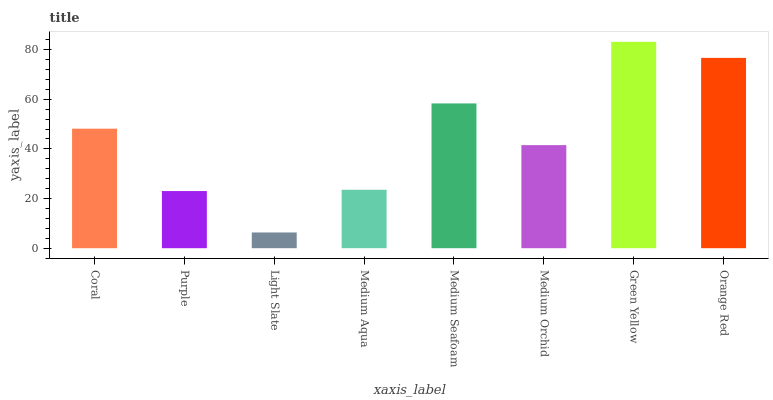Is Light Slate the minimum?
Answer yes or no. Yes. Is Green Yellow the maximum?
Answer yes or no. Yes. Is Purple the minimum?
Answer yes or no. No. Is Purple the maximum?
Answer yes or no. No. Is Coral greater than Purple?
Answer yes or no. Yes. Is Purple less than Coral?
Answer yes or no. Yes. Is Purple greater than Coral?
Answer yes or no. No. Is Coral less than Purple?
Answer yes or no. No. Is Coral the high median?
Answer yes or no. Yes. Is Medium Orchid the low median?
Answer yes or no. Yes. Is Medium Aqua the high median?
Answer yes or no. No. Is Purple the low median?
Answer yes or no. No. 